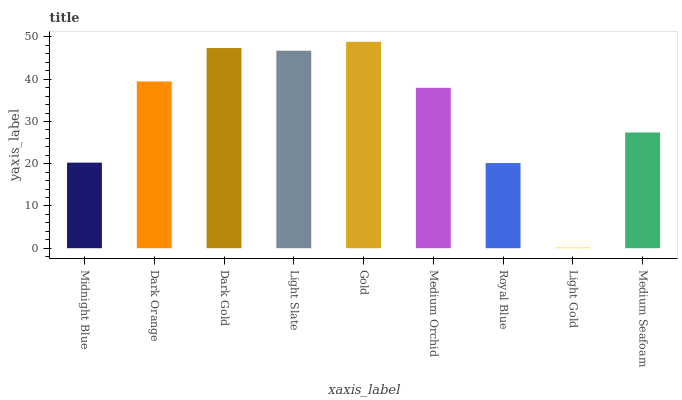Is Light Gold the minimum?
Answer yes or no. Yes. Is Gold the maximum?
Answer yes or no. Yes. Is Dark Orange the minimum?
Answer yes or no. No. Is Dark Orange the maximum?
Answer yes or no. No. Is Dark Orange greater than Midnight Blue?
Answer yes or no. Yes. Is Midnight Blue less than Dark Orange?
Answer yes or no. Yes. Is Midnight Blue greater than Dark Orange?
Answer yes or no. No. Is Dark Orange less than Midnight Blue?
Answer yes or no. No. Is Medium Orchid the high median?
Answer yes or no. Yes. Is Medium Orchid the low median?
Answer yes or no. Yes. Is Light Slate the high median?
Answer yes or no. No. Is Medium Seafoam the low median?
Answer yes or no. No. 